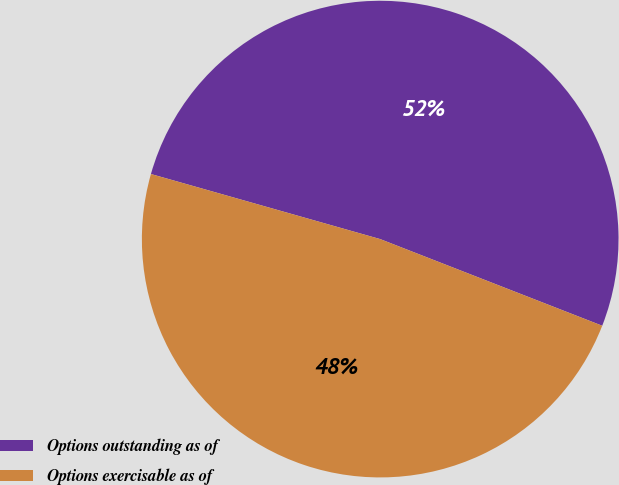Convert chart. <chart><loc_0><loc_0><loc_500><loc_500><pie_chart><fcel>Options outstanding as of<fcel>Options exercisable as of<nl><fcel>51.52%<fcel>48.48%<nl></chart> 